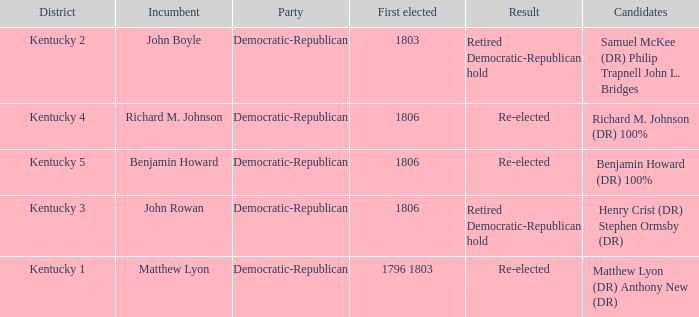Name the number of first elected for kentucky 3 1.0. 